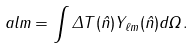Convert formula to latex. <formula><loc_0><loc_0><loc_500><loc_500>\ a l m = \int \Delta T ( \hat { n } ) Y _ { \ell m } ( \hat { n } ) d \Omega \, .</formula> 